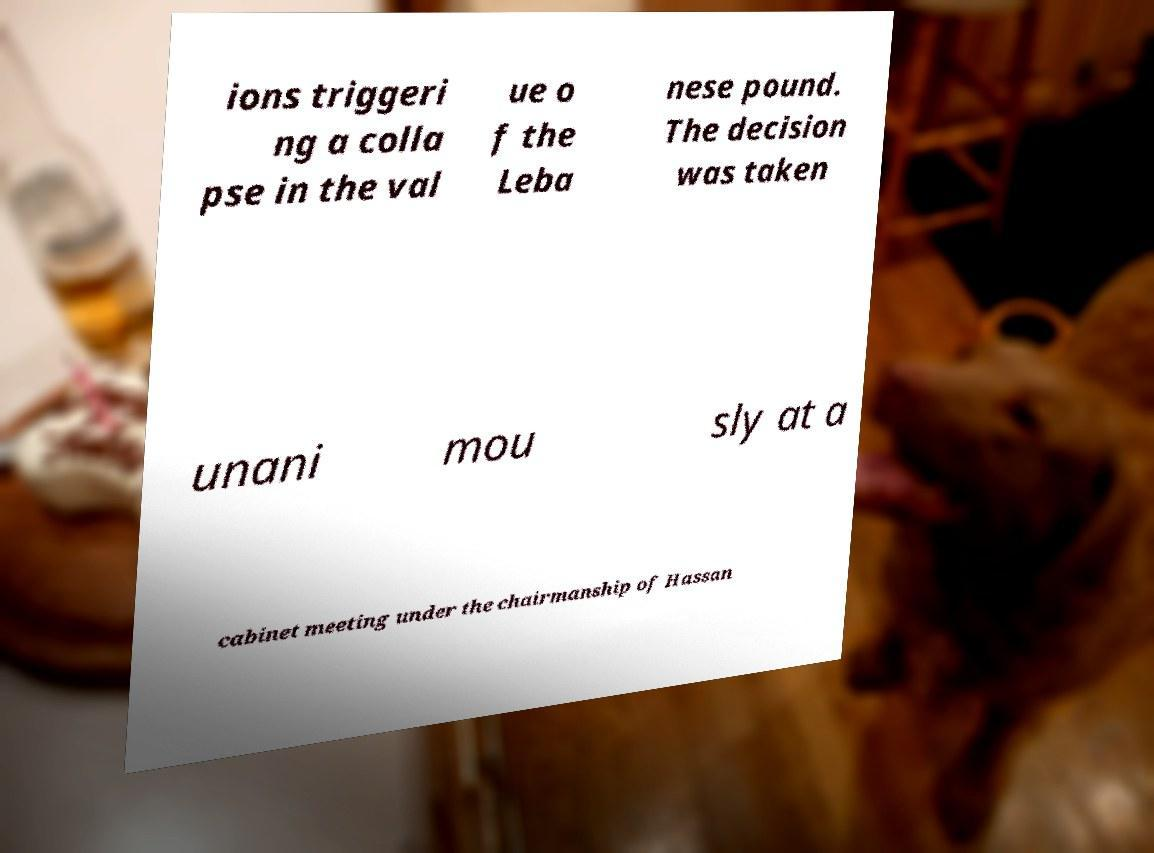Could you assist in decoding the text presented in this image and type it out clearly? ions triggeri ng a colla pse in the val ue o f the Leba nese pound. The decision was taken unani mou sly at a cabinet meeting under the chairmanship of Hassan 